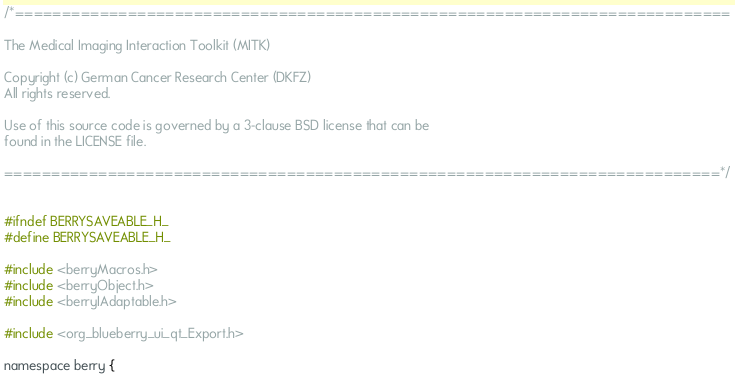Convert code to text. <code><loc_0><loc_0><loc_500><loc_500><_C_>/*============================================================================

The Medical Imaging Interaction Toolkit (MITK)

Copyright (c) German Cancer Research Center (DKFZ)
All rights reserved.

Use of this source code is governed by a 3-clause BSD license that can be
found in the LICENSE file.

============================================================================*/


#ifndef BERRYSAVEABLE_H_
#define BERRYSAVEABLE_H_

#include <berryMacros.h>
#include <berryObject.h>
#include <berryIAdaptable.h>

#include <org_blueberry_ui_qt_Export.h>

namespace berry {
</code> 